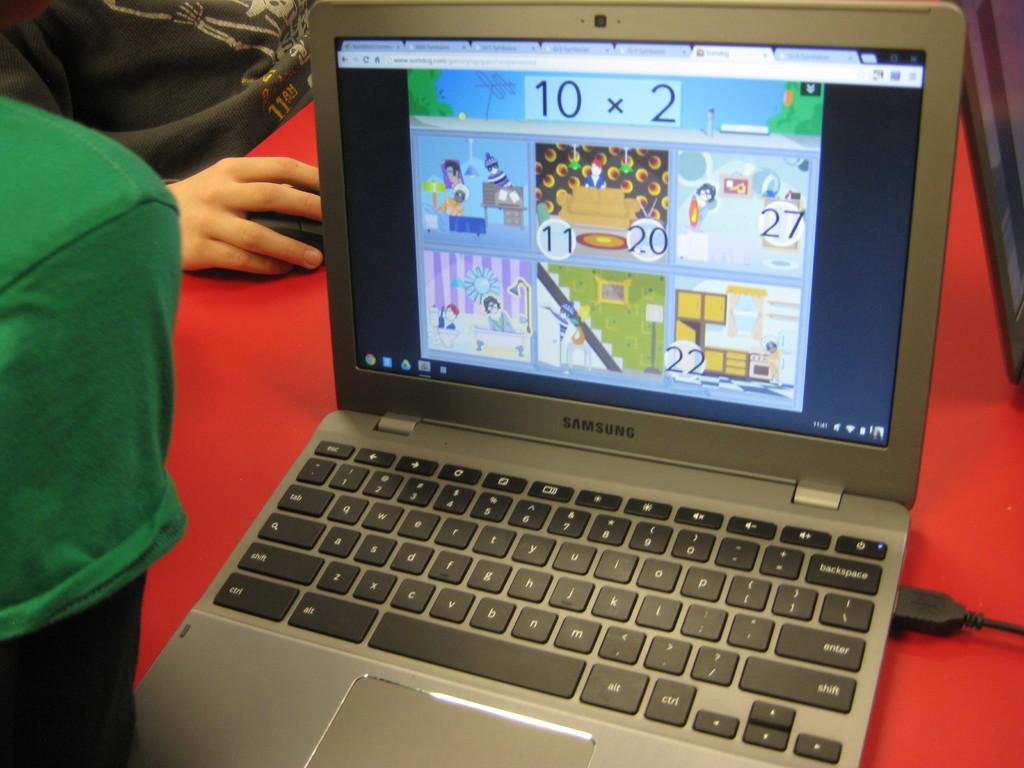What brand of laptop is this?
Provide a short and direct response. Samsung. 